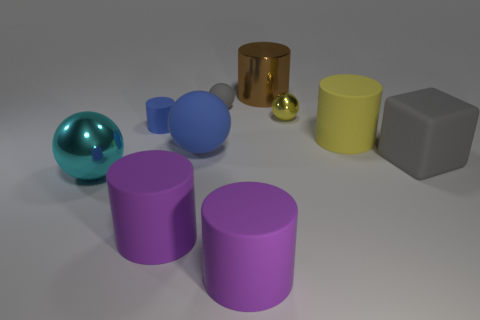Subtract 1 cylinders. How many cylinders are left? 4 Subtract all spheres. How many objects are left? 6 Subtract all large gray objects. Subtract all gray matte cubes. How many objects are left? 8 Add 2 matte blocks. How many matte blocks are left? 3 Add 8 metallic spheres. How many metallic spheres exist? 10 Subtract 0 green cylinders. How many objects are left? 10 